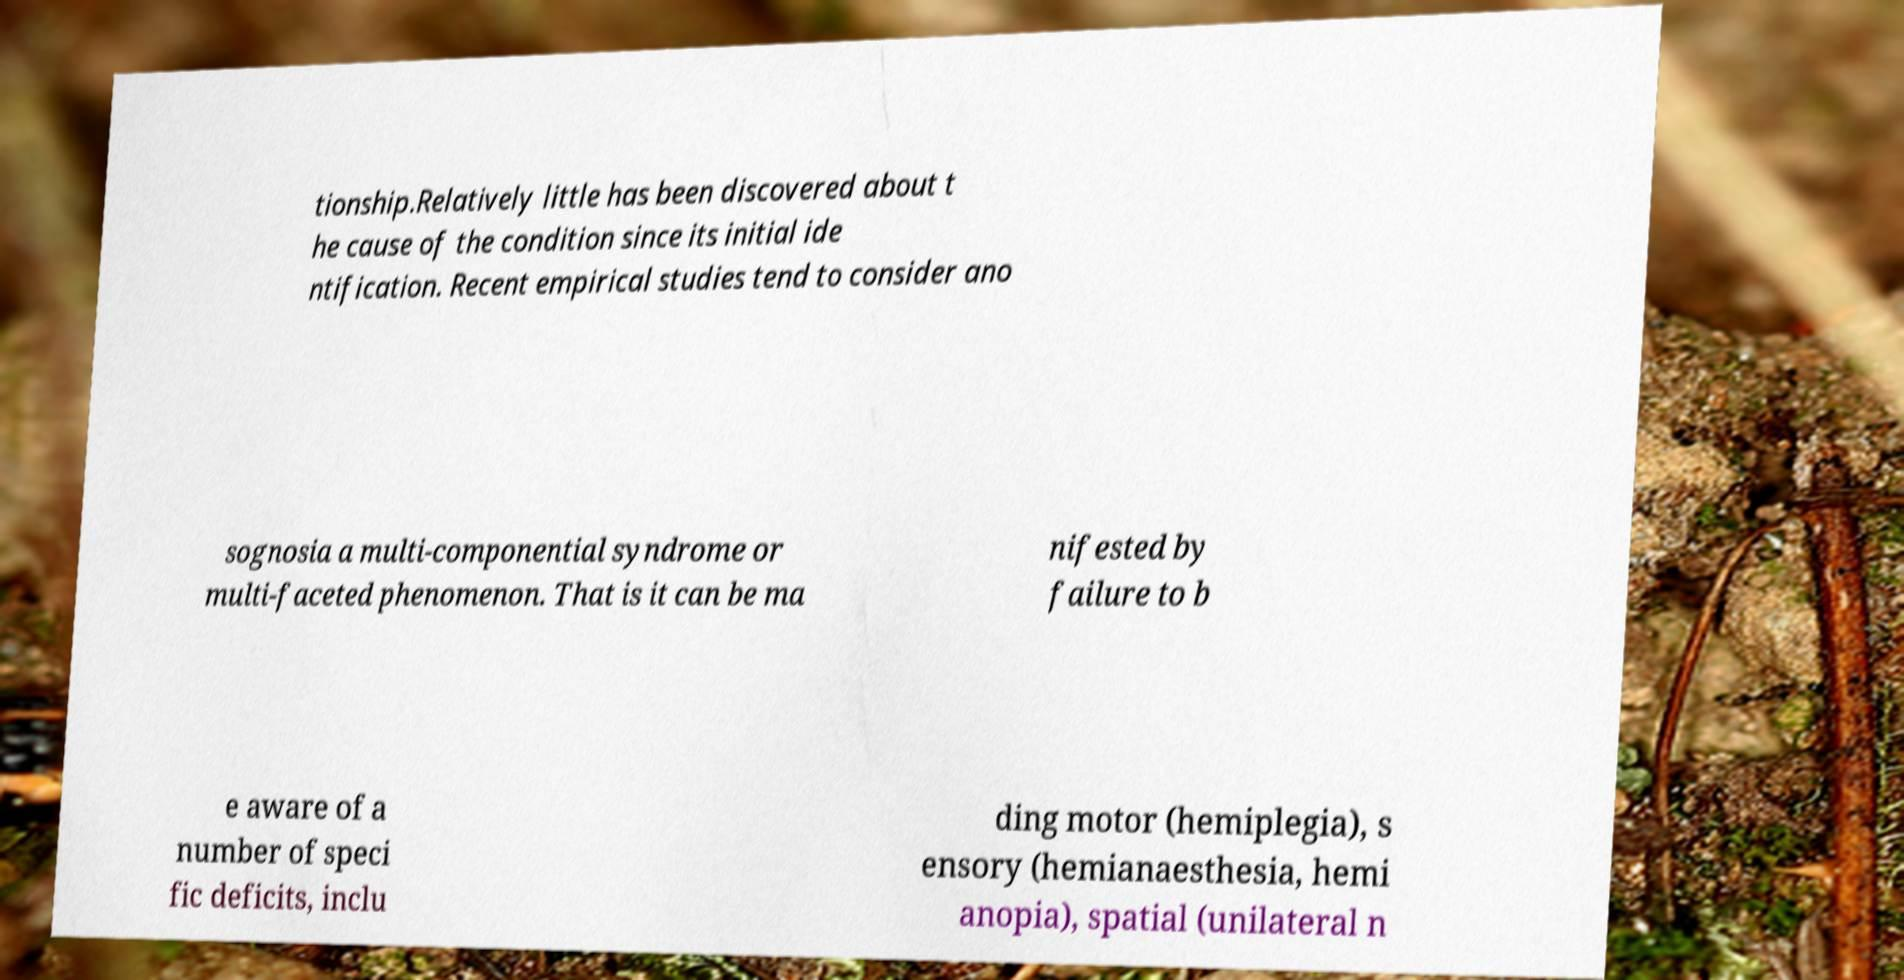For documentation purposes, I need the text within this image transcribed. Could you provide that? tionship.Relatively little has been discovered about t he cause of the condition since its initial ide ntification. Recent empirical studies tend to consider ano sognosia a multi-componential syndrome or multi-faceted phenomenon. That is it can be ma nifested by failure to b e aware of a number of speci fic deficits, inclu ding motor (hemiplegia), s ensory (hemianaesthesia, hemi anopia), spatial (unilateral n 